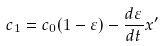Convert formula to latex. <formula><loc_0><loc_0><loc_500><loc_500>c _ { 1 } = c _ { 0 } ( 1 - \varepsilon ) - \frac { d \varepsilon } { d t } x ^ { \prime }</formula> 